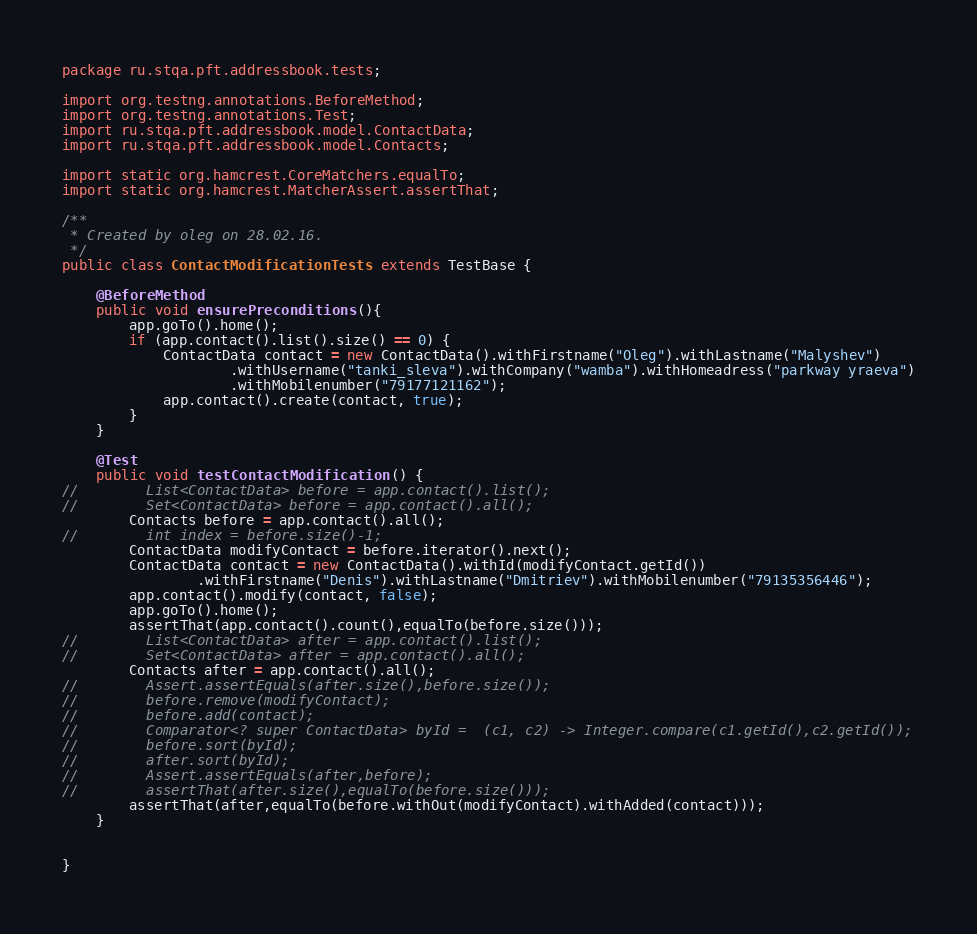Convert code to text. <code><loc_0><loc_0><loc_500><loc_500><_Java_>package ru.stqa.pft.addressbook.tests;

import org.testng.annotations.BeforeMethod;
import org.testng.annotations.Test;
import ru.stqa.pft.addressbook.model.ContactData;
import ru.stqa.pft.addressbook.model.Contacts;

import static org.hamcrest.CoreMatchers.equalTo;
import static org.hamcrest.MatcherAssert.assertThat;

/**
 * Created by oleg on 28.02.16.
 */
public class ContactModificationTests extends TestBase {

    @BeforeMethod
    public void ensurePreconditions(){
        app.goTo().home();
        if (app.contact().list().size() == 0) {
            ContactData contact = new ContactData().withFirstname("Oleg").withLastname("Malyshev")
                    .withUsername("tanki_sleva").withCompany("wamba").withHomeadress("parkway yraeva")
                    .withMobilenumber("79177121162");
            app.contact().create(contact, true);
        }
    }

    @Test
    public void testContactModification() {
//        List<ContactData> before = app.contact().list();
//        Set<ContactData> before = app.contact().all();
        Contacts before = app.contact().all();
//        int index = before.size()-1;
        ContactData modifyContact = before.iterator().next();
        ContactData contact = new ContactData().withId(modifyContact.getId())
                .withFirstname("Denis").withLastname("Dmitriev").withMobilenumber("79135356446");
        app.contact().modify(contact, false);
        app.goTo().home();
        assertThat(app.contact().count(),equalTo(before.size()));
//        List<ContactData> after = app.contact().list();
//        Set<ContactData> after = app.contact().all();
        Contacts after = app.contact().all();
//        Assert.assertEquals(after.size(),before.size());
//        before.remove(modifyContact);
//        before.add(contact);
//        Comparator<? super ContactData> byId =  (c1, c2) -> Integer.compare(c1.getId(),c2.getId());
//        before.sort(byId);
//        after.sort(byId);
//        Assert.assertEquals(after,before);
//        assertThat(after.size(),equalTo(before.size()));
        assertThat(after,equalTo(before.withOut(modifyContact).withAdded(contact)));
    }


}
</code> 